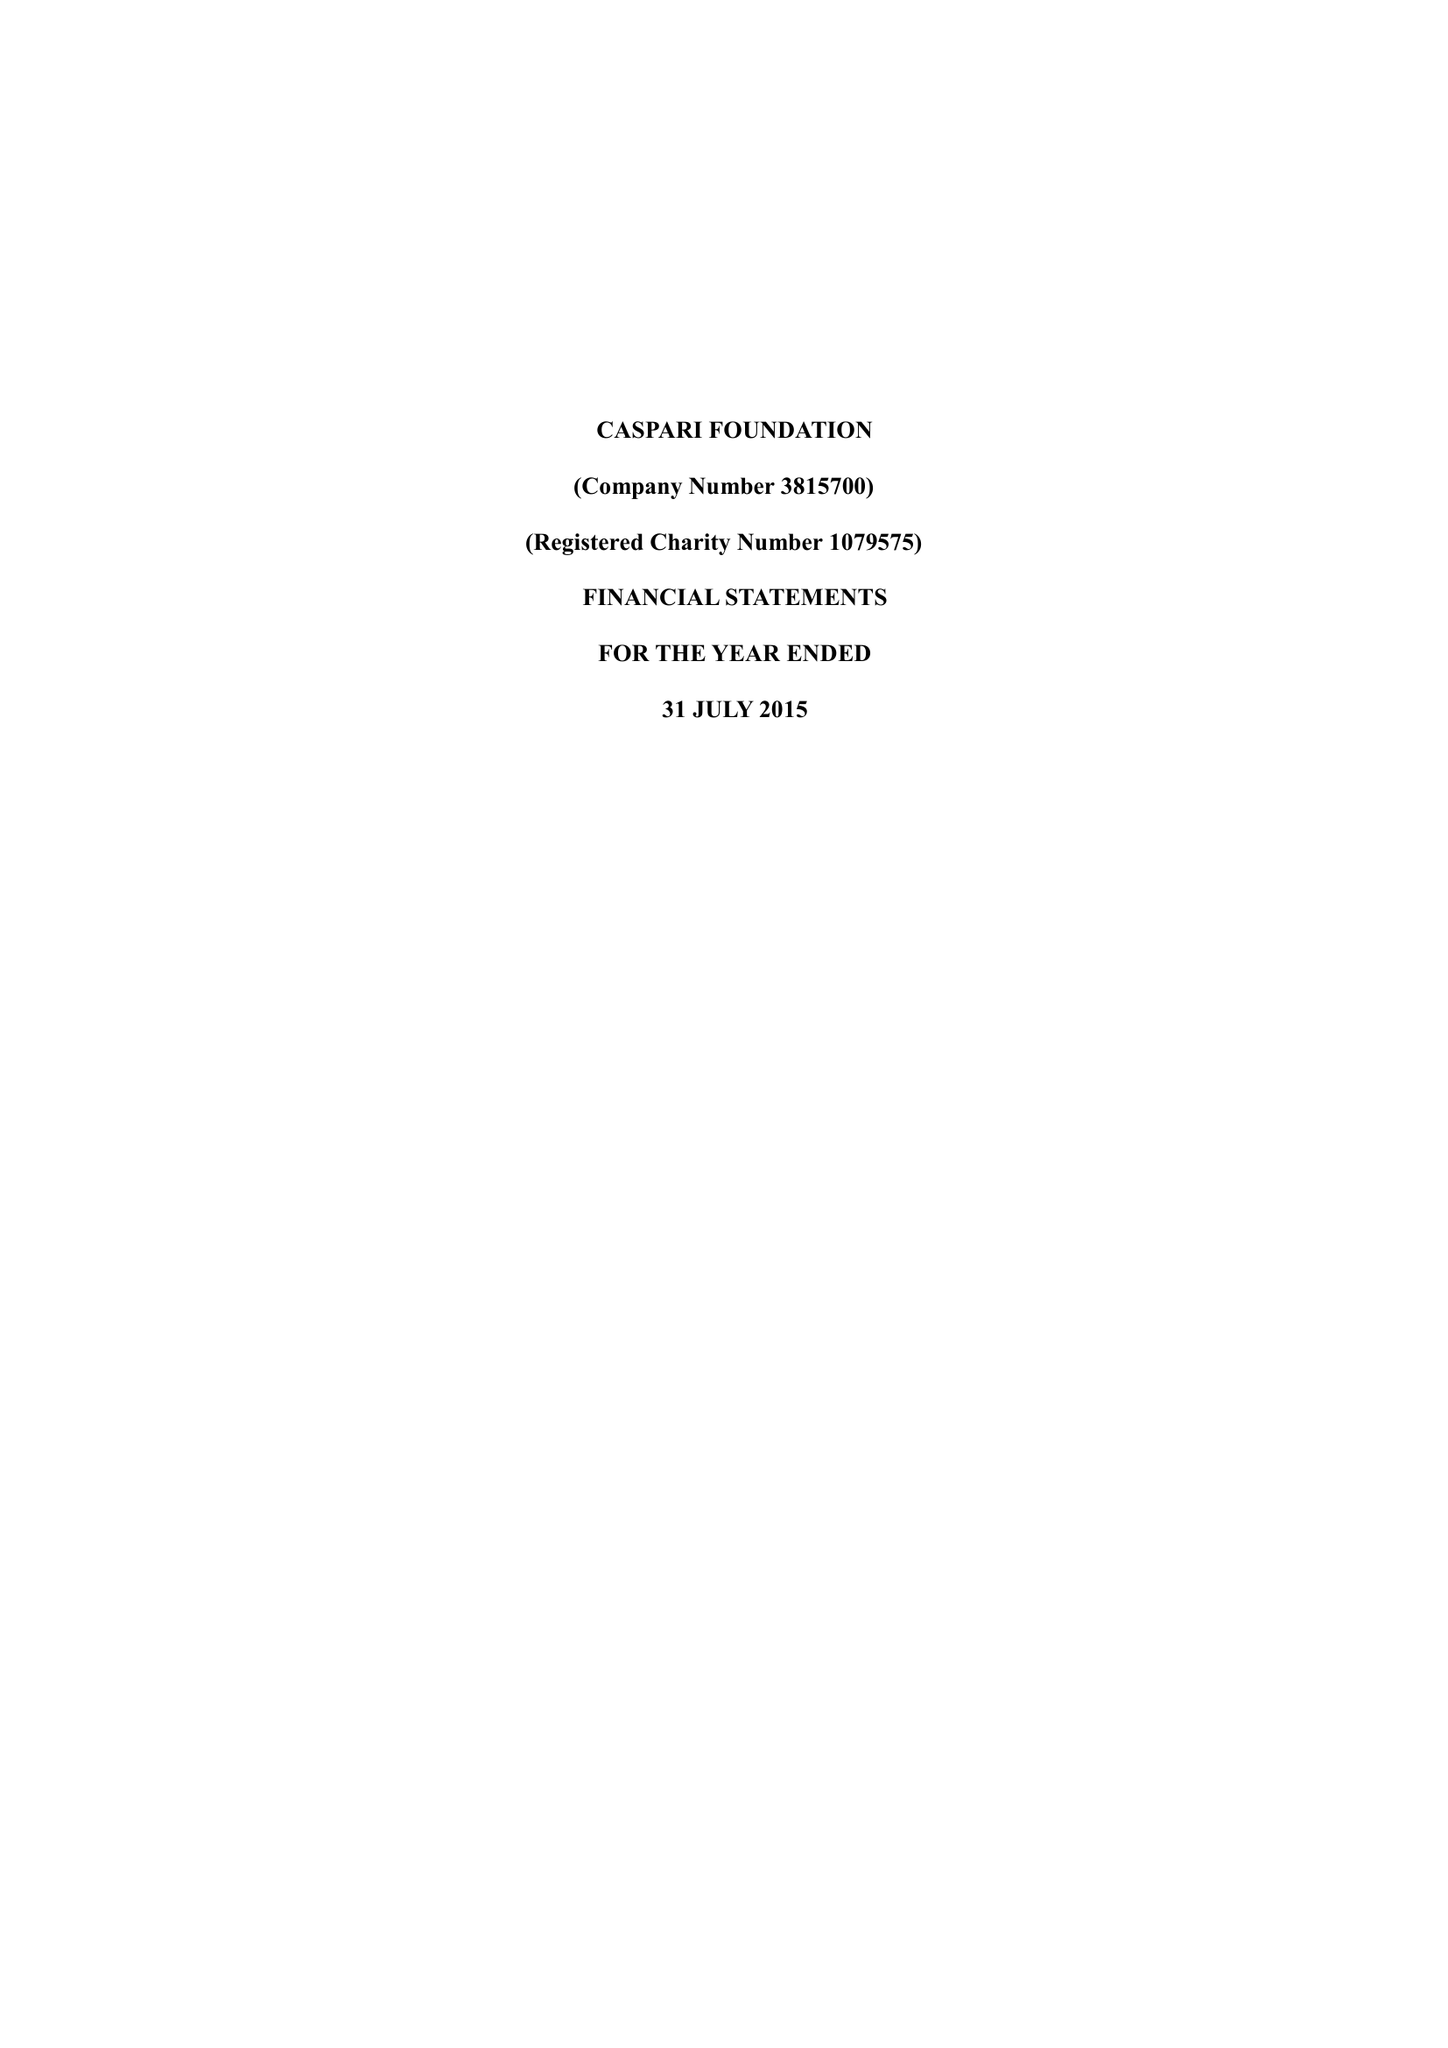What is the value for the charity_name?
Answer the question using a single word or phrase. Caspari Foundation 